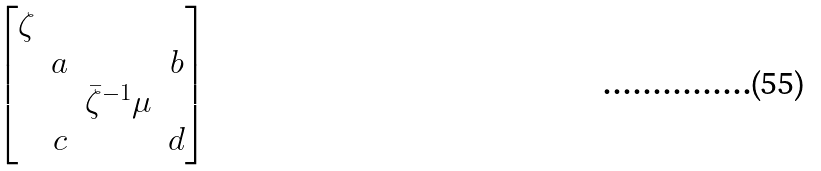Convert formula to latex. <formula><loc_0><loc_0><loc_500><loc_500>\begin{bmatrix} \zeta \\ & a & & b \\ & & \bar { \zeta } ^ { - 1 } \mu \\ & c & & d \end{bmatrix}</formula> 